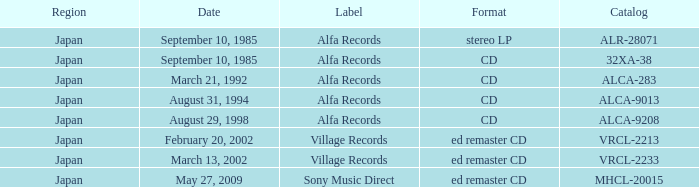Which catalog under the alfa records label was presented in a cd format? 32XA-38, ALCA-283, ALCA-9013, ALCA-9208. 